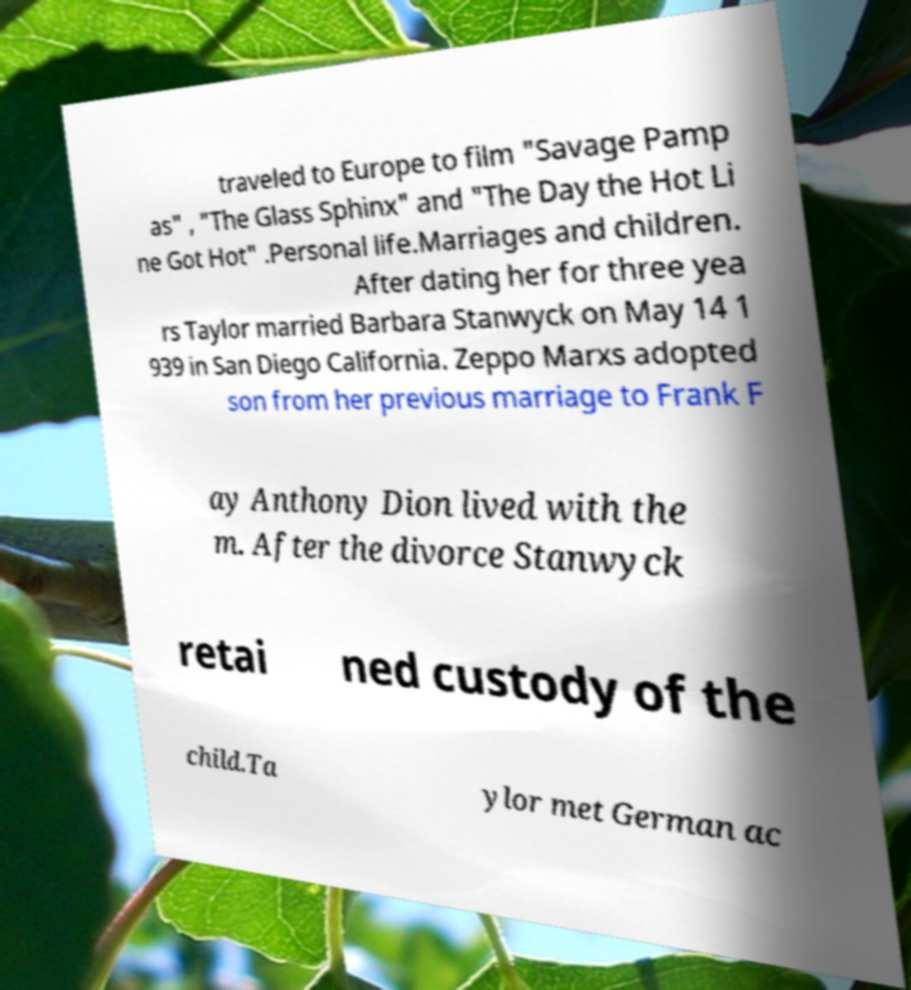There's text embedded in this image that I need extracted. Can you transcribe it verbatim? traveled to Europe to film "Savage Pamp as" , "The Glass Sphinx" and "The Day the Hot Li ne Got Hot" .Personal life.Marriages and children. After dating her for three yea rs Taylor married Barbara Stanwyck on May 14 1 939 in San Diego California. Zeppo Marxs adopted son from her previous marriage to Frank F ay Anthony Dion lived with the m. After the divorce Stanwyck retai ned custody of the child.Ta ylor met German ac 